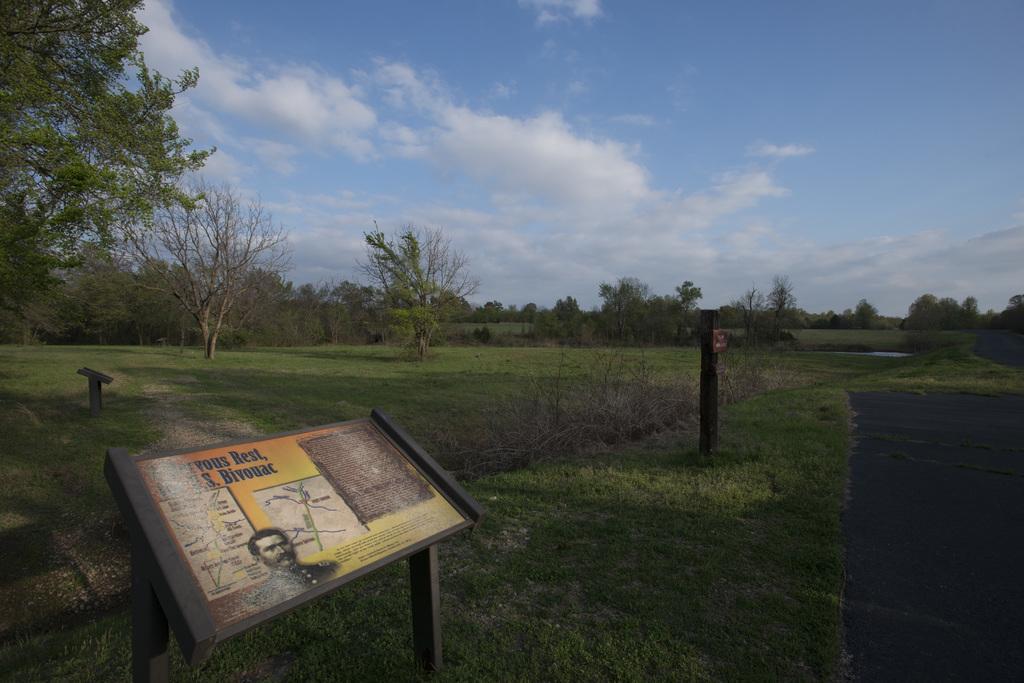In one or two sentences, can you explain what this image depicts? In this image I can see the board. On the board I can see the person and the text. It is to the side of the road. In the background I can see the trees, clouds and the blue sky. 